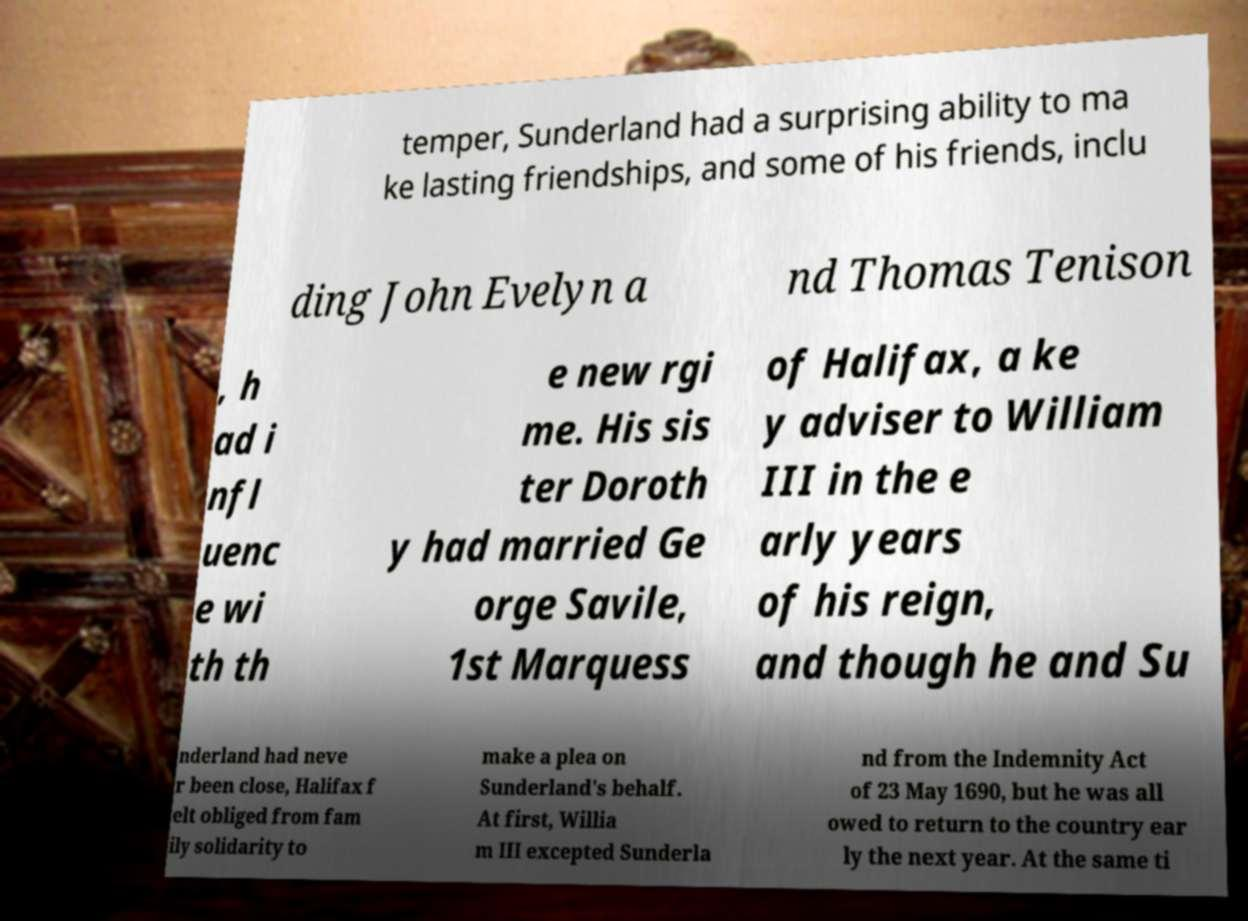I need the written content from this picture converted into text. Can you do that? temper, Sunderland had a surprising ability to ma ke lasting friendships, and some of his friends, inclu ding John Evelyn a nd Thomas Tenison , h ad i nfl uenc e wi th th e new rgi me. His sis ter Doroth y had married Ge orge Savile, 1st Marquess of Halifax, a ke y adviser to William III in the e arly years of his reign, and though he and Su nderland had neve r been close, Halifax f elt obliged from fam ily solidarity to make a plea on Sunderland's behalf. At first, Willia m III excepted Sunderla nd from the Indemnity Act of 23 May 1690, but he was all owed to return to the country ear ly the next year. At the same ti 